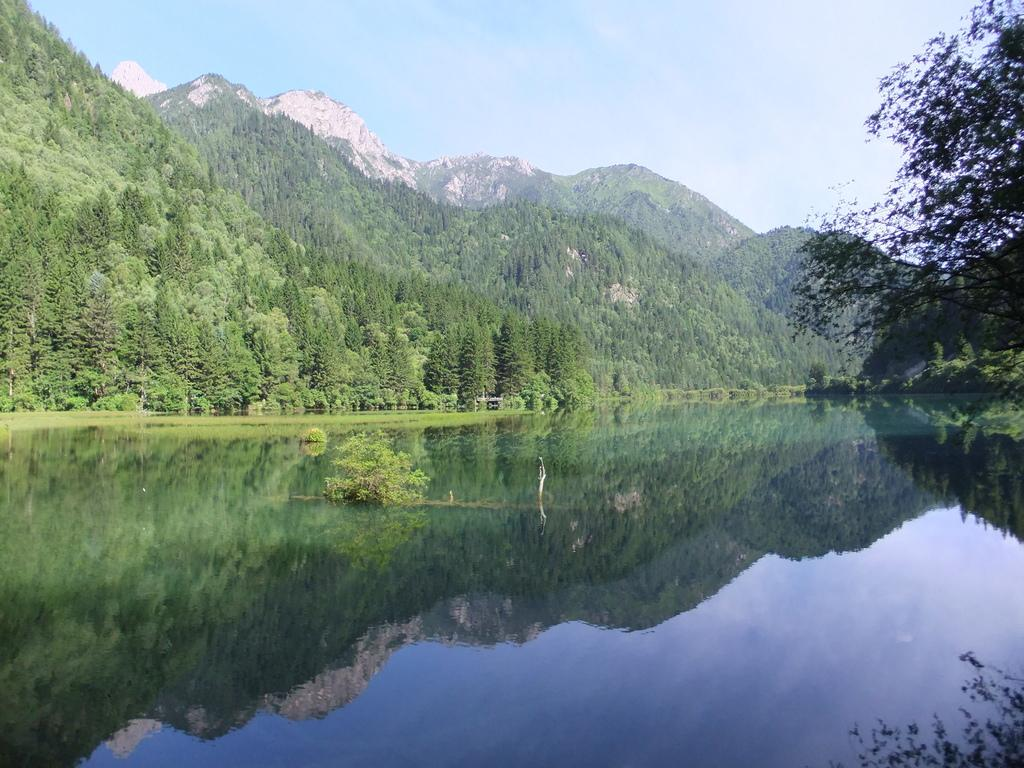What is the primary element visible in the image? There is water in the image. What other natural elements can be seen in the image? There are plants and trees visible in the image. What can be seen in the distance in the background of the image? There are mountains and the sky visible in the background of the image. What type of hammer is being used by the kitty in the image? There is no kitty or hammer present in the image. 